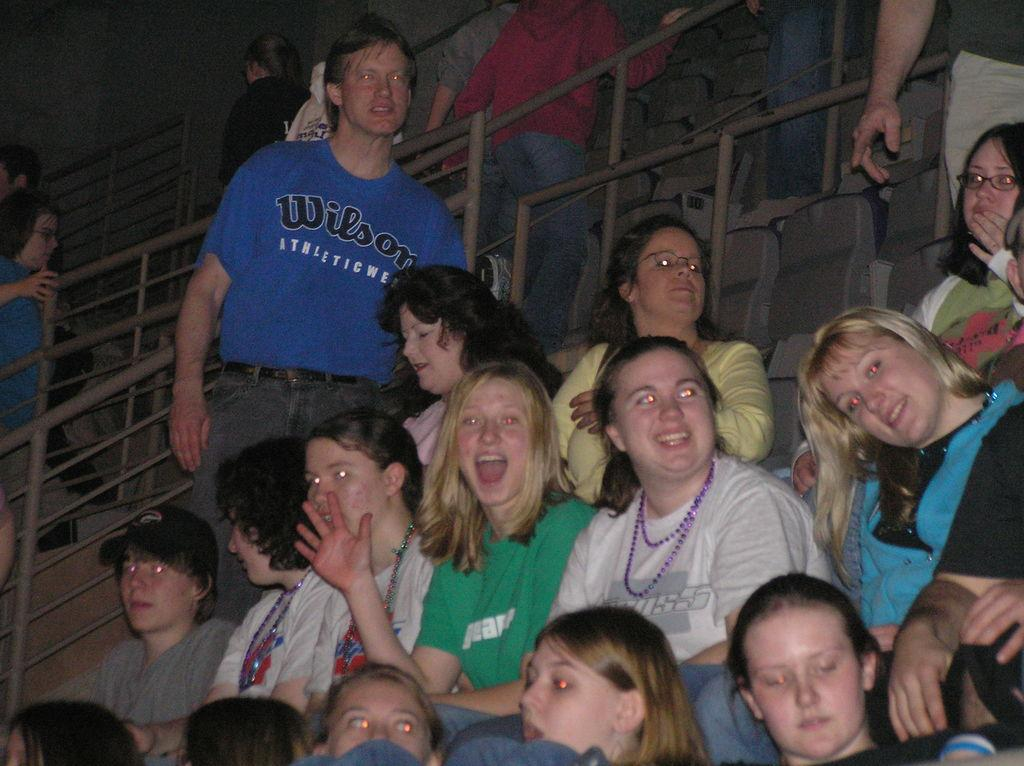What is the main subject of the image? The main subject of the image is a group of people. What are some of the people in the image doing? Some people are sitting on chairs, and some are standing. How are the people who are sitting on chairs feeling? The people who are sitting on chairs are smiling. What can be seen in the background of the image? There is a fence in the image. What type of rake is being used by the people in the image? There is no rake present in the image; it features a group of people sitting on chairs, standing, and smiling. How does the wealth of the people in the image affect their expressions? The provided facts do not mention the wealth of the people in the image, so we cannot determine how it might affect their expressions. 